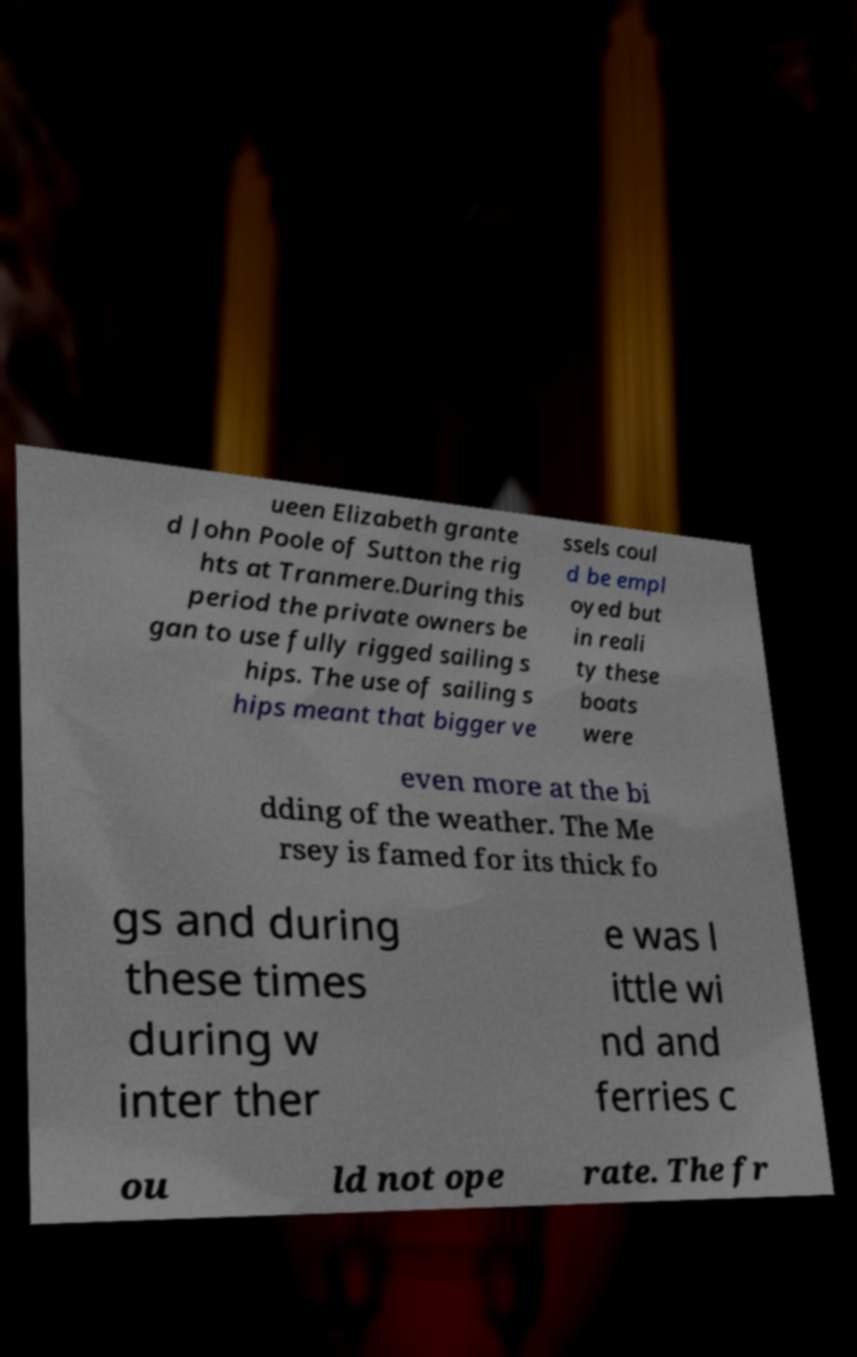Please read and relay the text visible in this image. What does it say? ueen Elizabeth grante d John Poole of Sutton the rig hts at Tranmere.During this period the private owners be gan to use fully rigged sailing s hips. The use of sailing s hips meant that bigger ve ssels coul d be empl oyed but in reali ty these boats were even more at the bi dding of the weather. The Me rsey is famed for its thick fo gs and during these times during w inter ther e was l ittle wi nd and ferries c ou ld not ope rate. The fr 